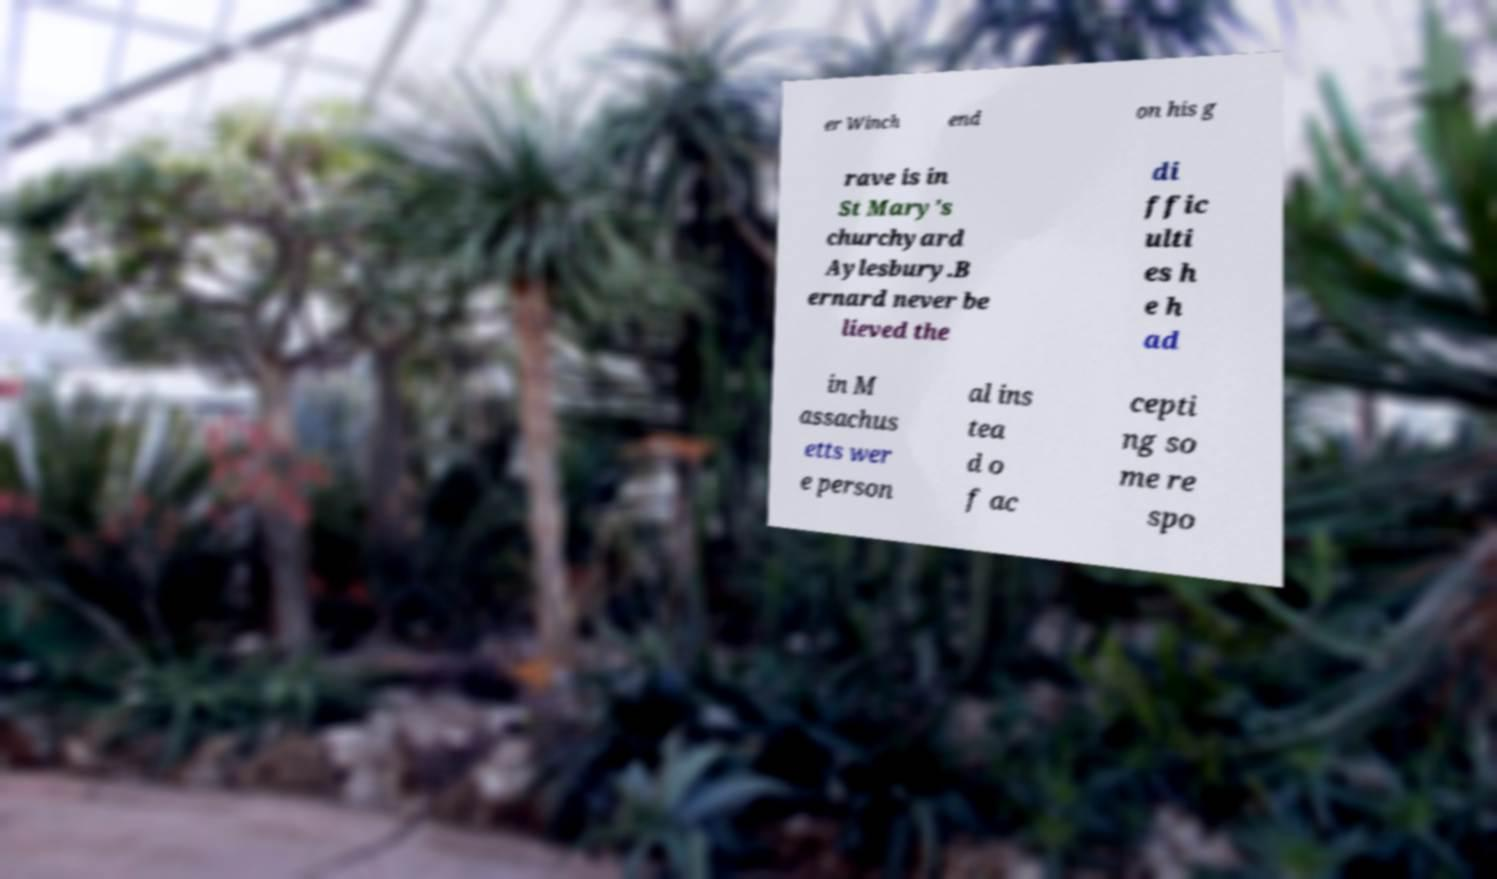Could you extract and type out the text from this image? er Winch end on his g rave is in St Mary's churchyard Aylesbury.B ernard never be lieved the di ffic ulti es h e h ad in M assachus etts wer e person al ins tea d o f ac cepti ng so me re spo 